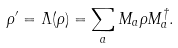<formula> <loc_0><loc_0><loc_500><loc_500>\rho ^ { \prime } = \Lambda ( \rho ) = \sum _ { a } M _ { a } \rho M ^ { \dagger } _ { a } .</formula> 